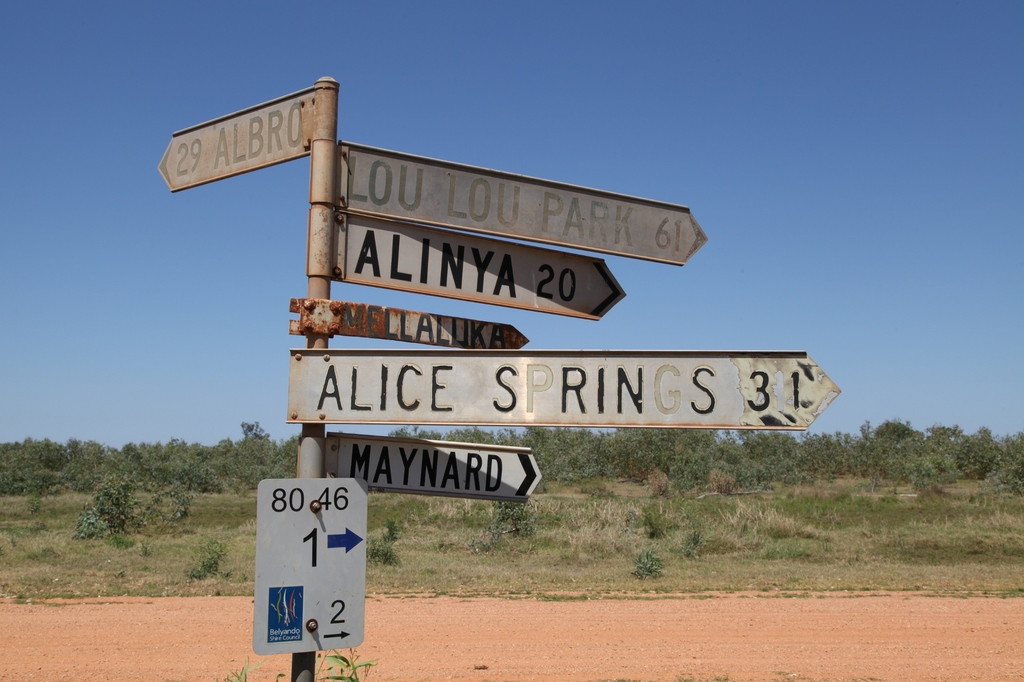What does the kangaroo symbol on the sign indicate? The kangaroo symbol on the sign is an important indicator for drivers, signifying the presence or frequent crossing of kangaroos in the area. This is crucial for road safety in rural and outback Australia, where wildlife on the road can pose significant hazards, especially during dawn and dusk when animals are most active. It serves as a reminder to motorists to remain vigilant and drive cautiously to avoid collisions with these native animals. 